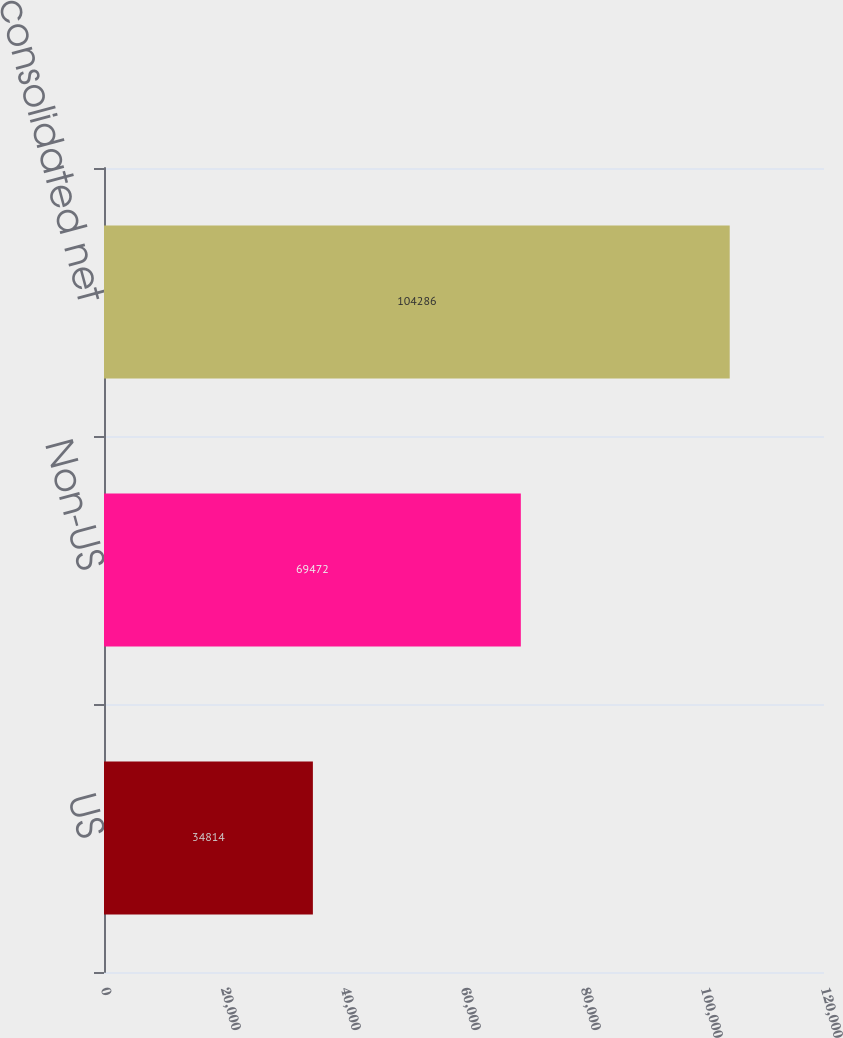<chart> <loc_0><loc_0><loc_500><loc_500><bar_chart><fcel>US<fcel>Non-US<fcel>Total HP consolidated net<nl><fcel>34814<fcel>69472<fcel>104286<nl></chart> 